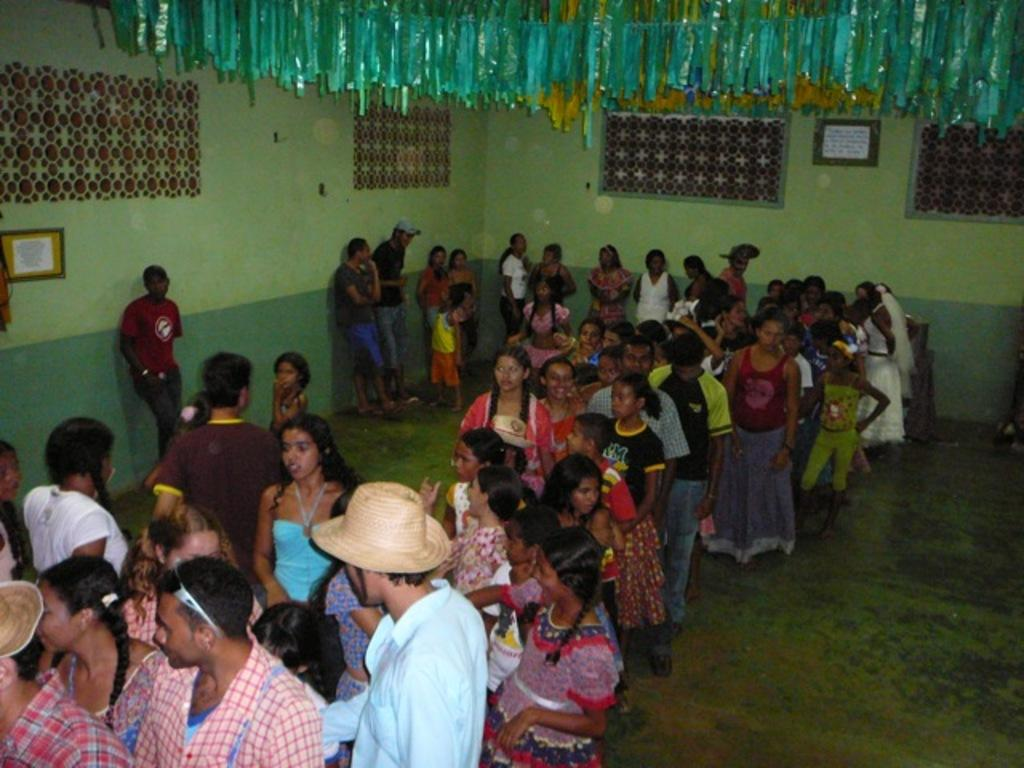Who is present in the image? There are people in the image, including kids. What can be seen on the walls in the image? There are frames on the walls. Are there any decorative items visible in the image? Yes, there are decorative items on top of the picture. What type of board can be seen in the image? There is no board present in the image. Are there any icicles hanging from the decorative items in the image? There are no icicles visible in the image, as it does not depict a cold or snowy environment. 